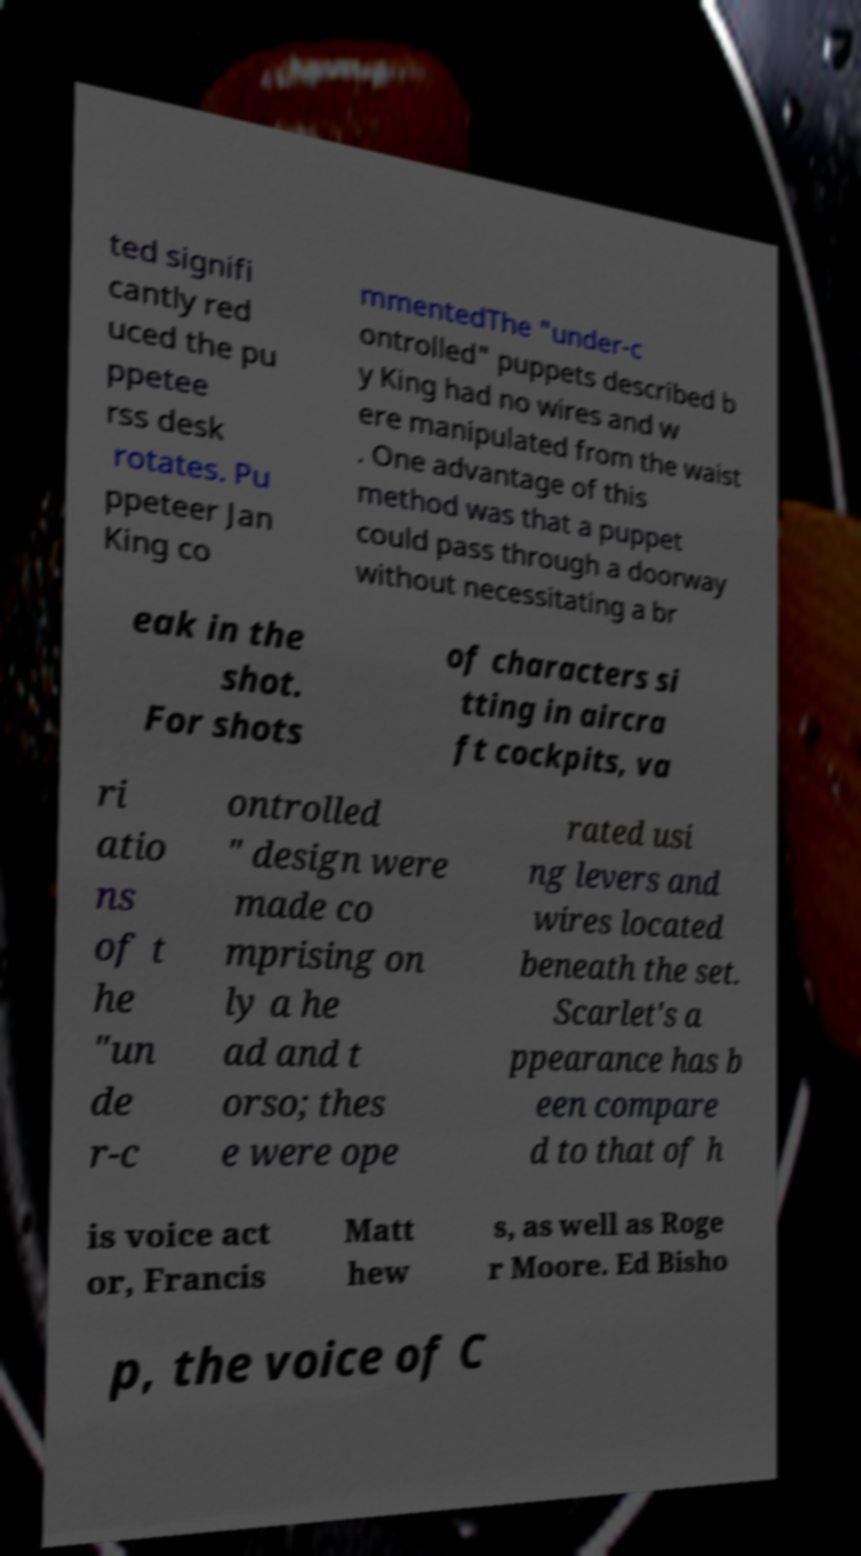What messages or text are displayed in this image? I need them in a readable, typed format. ted signifi cantly red uced the pu ppetee rss desk rotates. Pu ppeteer Jan King co mmentedThe "under-c ontrolled" puppets described b y King had no wires and w ere manipulated from the waist . One advantage of this method was that a puppet could pass through a doorway without necessitating a br eak in the shot. For shots of characters si tting in aircra ft cockpits, va ri atio ns of t he "un de r-c ontrolled " design were made co mprising on ly a he ad and t orso; thes e were ope rated usi ng levers and wires located beneath the set. Scarlet's a ppearance has b een compare d to that of h is voice act or, Francis Matt hew s, as well as Roge r Moore. Ed Bisho p, the voice of C 